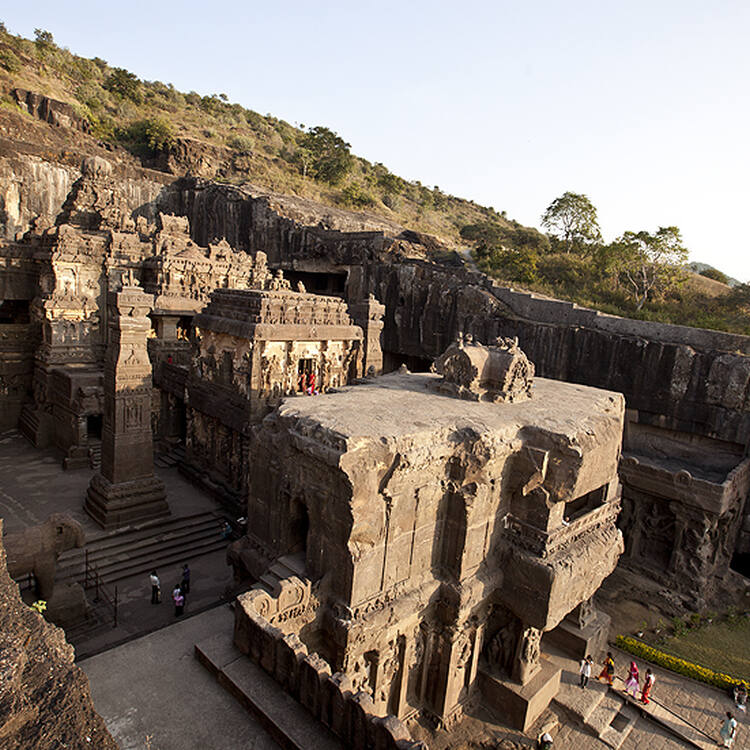Can you describe the main features of this image for me? The image showcases the Ellora Caves, a UNESCO World Heritage Site in India, viewed from an elevated perspective. The caves are carved into the side of a cliff, with their dark stone contrasting beautifully against the blue sky and surrounding green foliage. The architectural marvels feature intricate carvings and details that highlight the craftsmanship of ancient times. In the central open area, people provide a sense of scale to the vastness of the caves. The image reflects the historical and architectural significance of the Ellora Caves, continuing to captivate and inspire visitors with their grandeur and enduring legacy. 